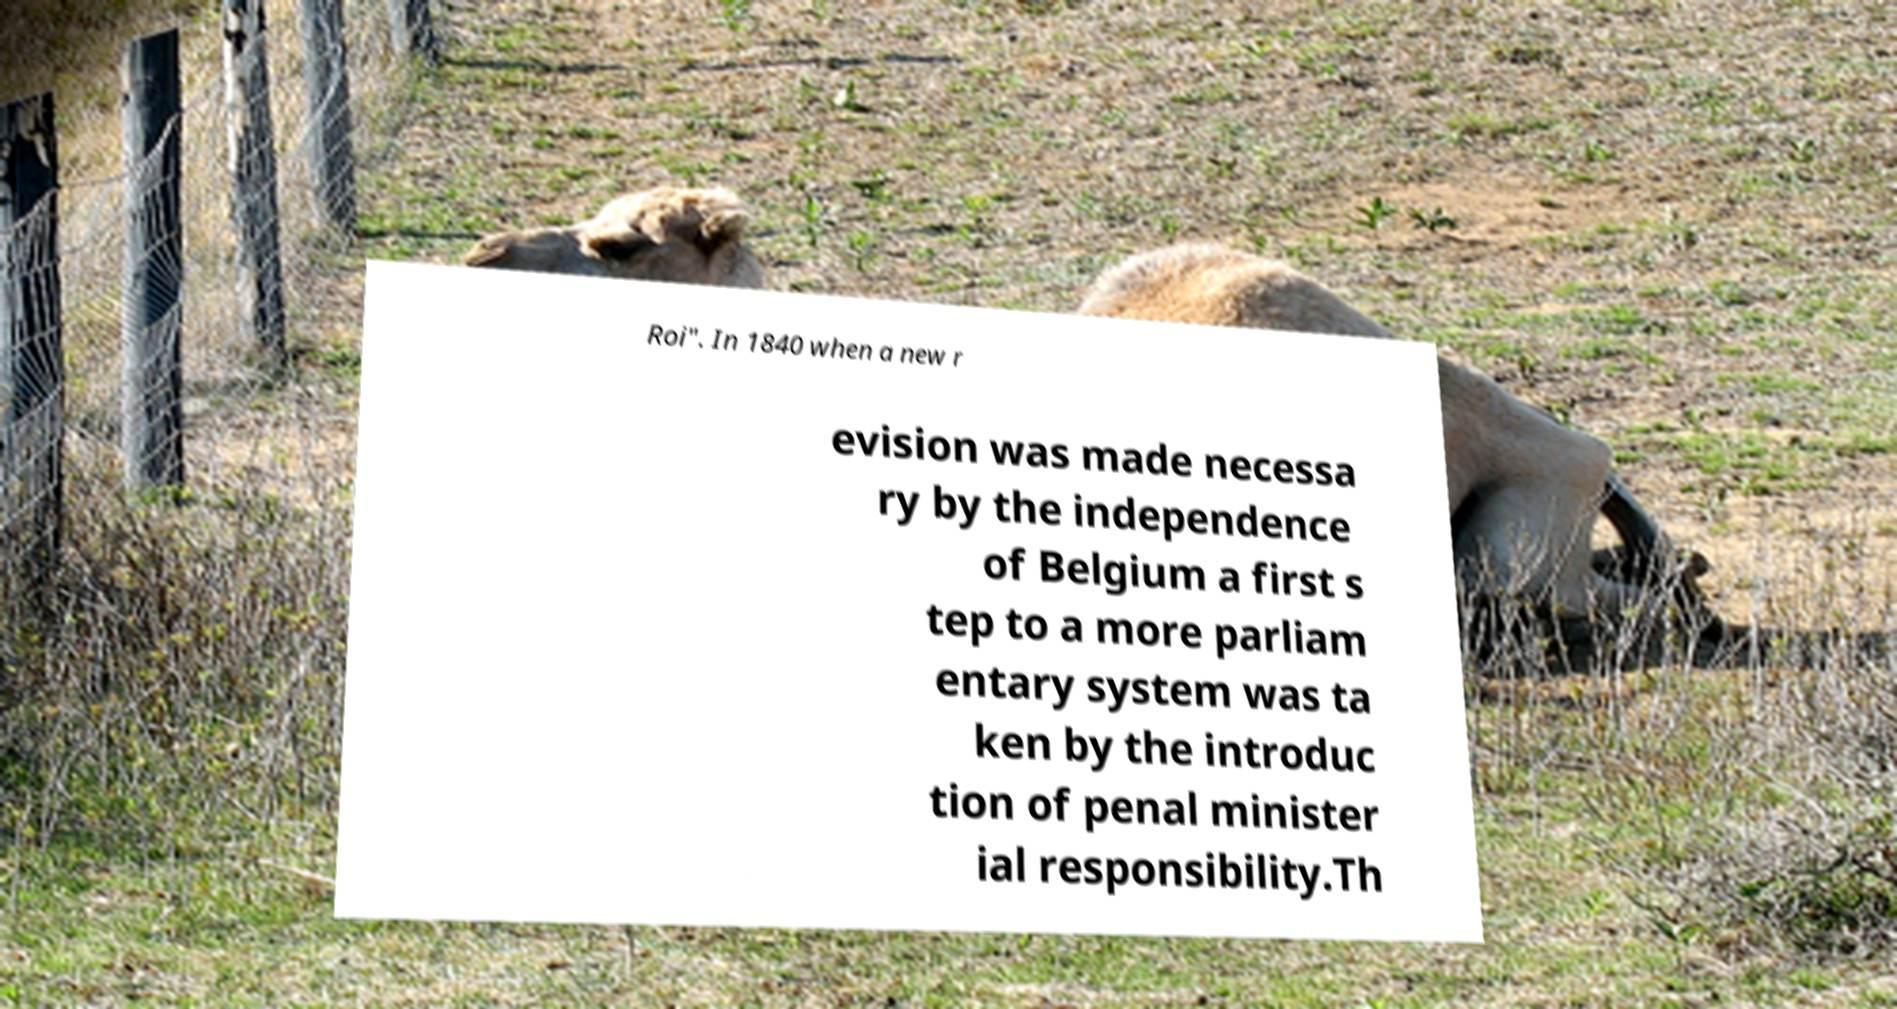Can you accurately transcribe the text from the provided image for me? Roi". In 1840 when a new r evision was made necessa ry by the independence of Belgium a first s tep to a more parliam entary system was ta ken by the introduc tion of penal minister ial responsibility.Th 